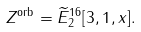<formula> <loc_0><loc_0><loc_500><loc_500>Z ^ { \text {orb} } & = \widetilde { E } ^ { 1 6 } _ { 2 } [ 3 , 1 , x ] .</formula> 